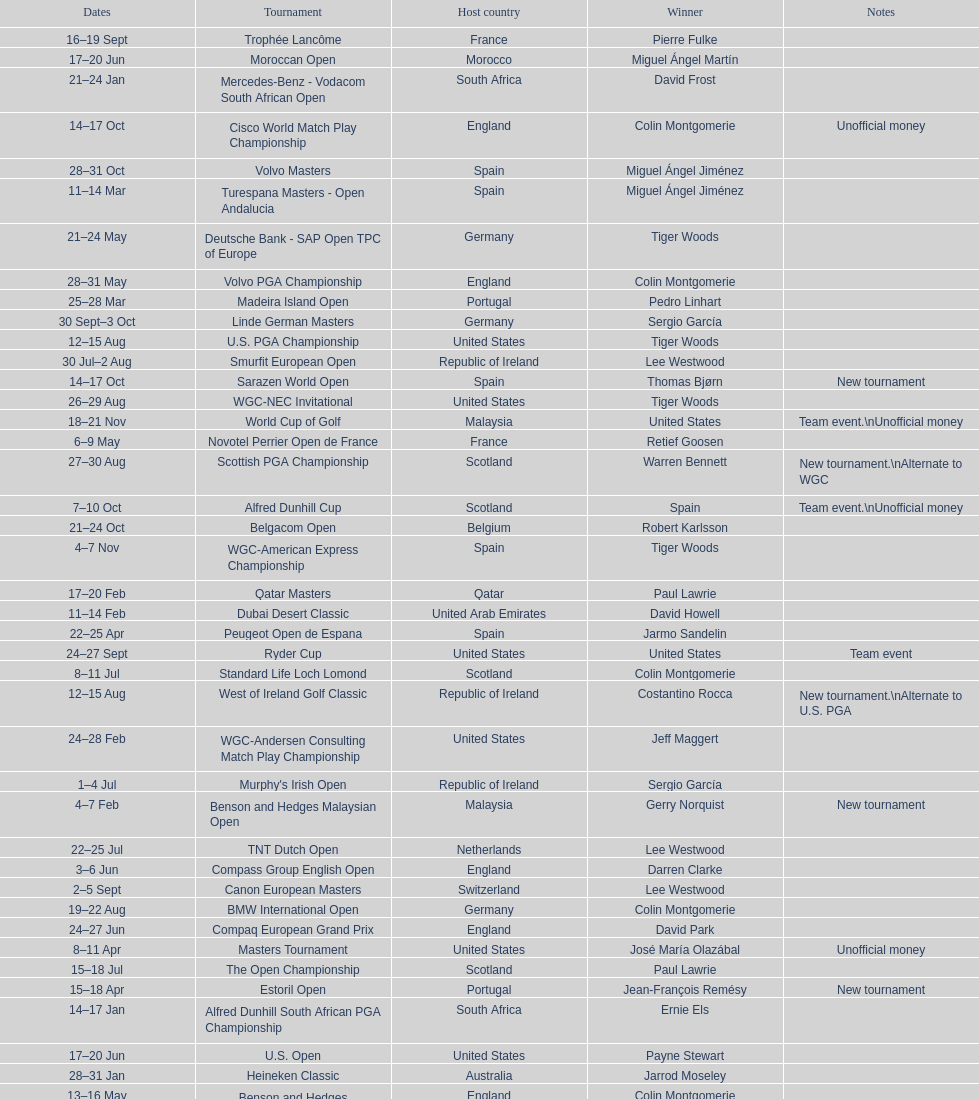What was the country listed the first time there was a new tournament? Malaysia. 